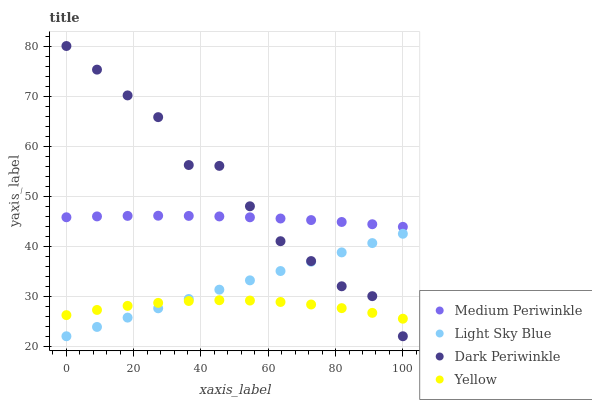Does Yellow have the minimum area under the curve?
Answer yes or no. Yes. Does Dark Periwinkle have the maximum area under the curve?
Answer yes or no. Yes. Does Medium Periwinkle have the minimum area under the curve?
Answer yes or no. No. Does Medium Periwinkle have the maximum area under the curve?
Answer yes or no. No. Is Light Sky Blue the smoothest?
Answer yes or no. Yes. Is Dark Periwinkle the roughest?
Answer yes or no. Yes. Is Medium Periwinkle the smoothest?
Answer yes or no. No. Is Medium Periwinkle the roughest?
Answer yes or no. No. Does Light Sky Blue have the lowest value?
Answer yes or no. Yes. Does Medium Periwinkle have the lowest value?
Answer yes or no. No. Does Dark Periwinkle have the highest value?
Answer yes or no. Yes. Does Medium Periwinkle have the highest value?
Answer yes or no. No. Is Light Sky Blue less than Medium Periwinkle?
Answer yes or no. Yes. Is Medium Periwinkle greater than Light Sky Blue?
Answer yes or no. Yes. Does Yellow intersect Dark Periwinkle?
Answer yes or no. Yes. Is Yellow less than Dark Periwinkle?
Answer yes or no. No. Is Yellow greater than Dark Periwinkle?
Answer yes or no. No. Does Light Sky Blue intersect Medium Periwinkle?
Answer yes or no. No. 